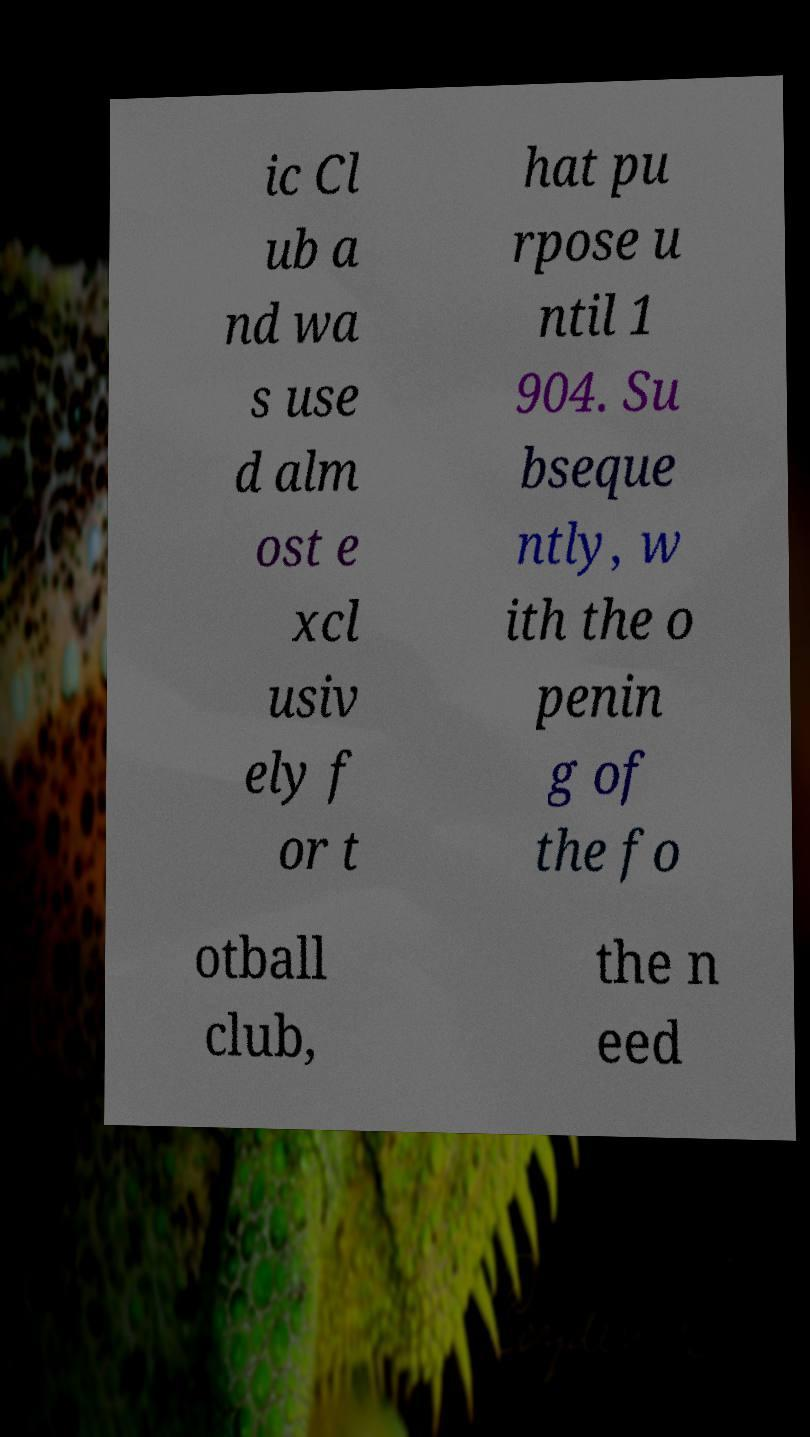Could you extract and type out the text from this image? ic Cl ub a nd wa s use d alm ost e xcl usiv ely f or t hat pu rpose u ntil 1 904. Su bseque ntly, w ith the o penin g of the fo otball club, the n eed 